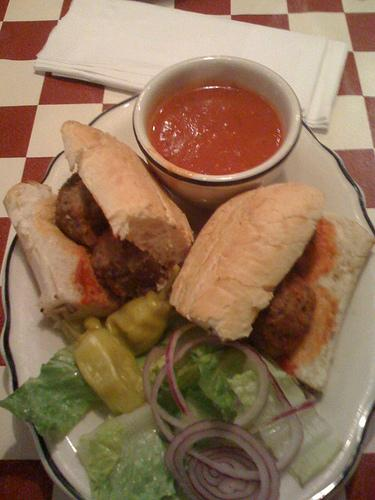What type of pepper is on the plate?

Choices:
A) jalapeno
B) cherry pepper
C) pepperoncini
D) red pepper pepperoncini 